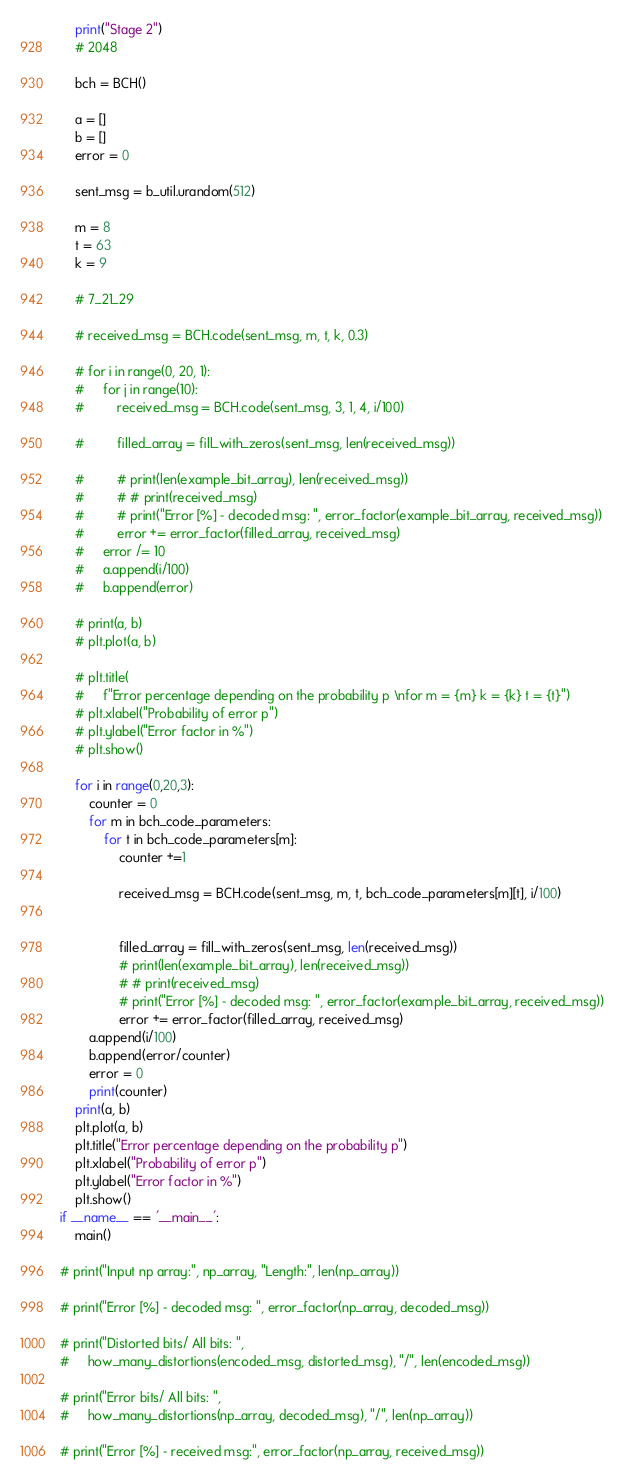<code> <loc_0><loc_0><loc_500><loc_500><_Python_>    print("Stage 2")
    # 2048

    bch = BCH()

    a = []
    b = []
    error = 0

    sent_msg = b_util.urandom(512)

    m = 8
    t = 63
    k = 9

    # 7_21_29

    # received_msg = BCH.code(sent_msg, m, t, k, 0.3)

    # for i in range(0, 20, 1):
    #     for j in range(10):
    #         received_msg = BCH.code(sent_msg, 3, 1, 4, i/100)

    #         filled_array = fill_with_zeros(sent_msg, len(received_msg))

    #         # print(len(example_bit_array), len(received_msg))
    #         # # print(received_msg)
    #         # print("Error [%] - decoded msg: ", error_factor(example_bit_array, received_msg))
    #         error += error_factor(filled_array, received_msg)
    #     error /= 10
    #     a.append(i/100)
    #     b.append(error)

    # print(a, b)
    # plt.plot(a, b)

    # plt.title(
    #     f"Error percentage depending on the probability p \nfor m = {m} k = {k} t = {t}")
    # plt.xlabel("Probability of error p")
    # plt.ylabel("Error factor in %")
    # plt.show()

    for i in range(0,20,3):
        counter = 0
        for m in bch_code_parameters:
            for t in bch_code_parameters[m]:
                counter +=1

                received_msg = BCH.code(sent_msg, m, t, bch_code_parameters[m][t], i/100)


                filled_array = fill_with_zeros(sent_msg, len(received_msg))
                # print(len(example_bit_array), len(received_msg))
                # # print(received_msg)
                # print("Error [%] - decoded msg: ", error_factor(example_bit_array, received_msg))
                error += error_factor(filled_array, received_msg)
        a.append(i/100)
        b.append(error/counter)
        error = 0
        print(counter)
    print(a, b)
    plt.plot(a, b)
    plt.title("Error percentage depending on the probability p")
    plt.xlabel("Probability of error p")
    plt.ylabel("Error factor in %")
    plt.show()
if __name__ == '__main__':
    main()

# print("Input np array:", np_array, "Length:", len(np_array))

# print("Error [%] - decoded msg: ", error_factor(np_array, decoded_msg))

# print("Distorted bits/ All bits: ",
#     how_many_distortions(encoded_msg, distorted_msg), "/", len(encoded_msg))

# print("Error bits/ All bits: ",
#     how_many_distortions(np_array, decoded_msg), "/", len(np_array))

# print("Error [%] - received msg:", error_factor(np_array, received_msg))
</code> 